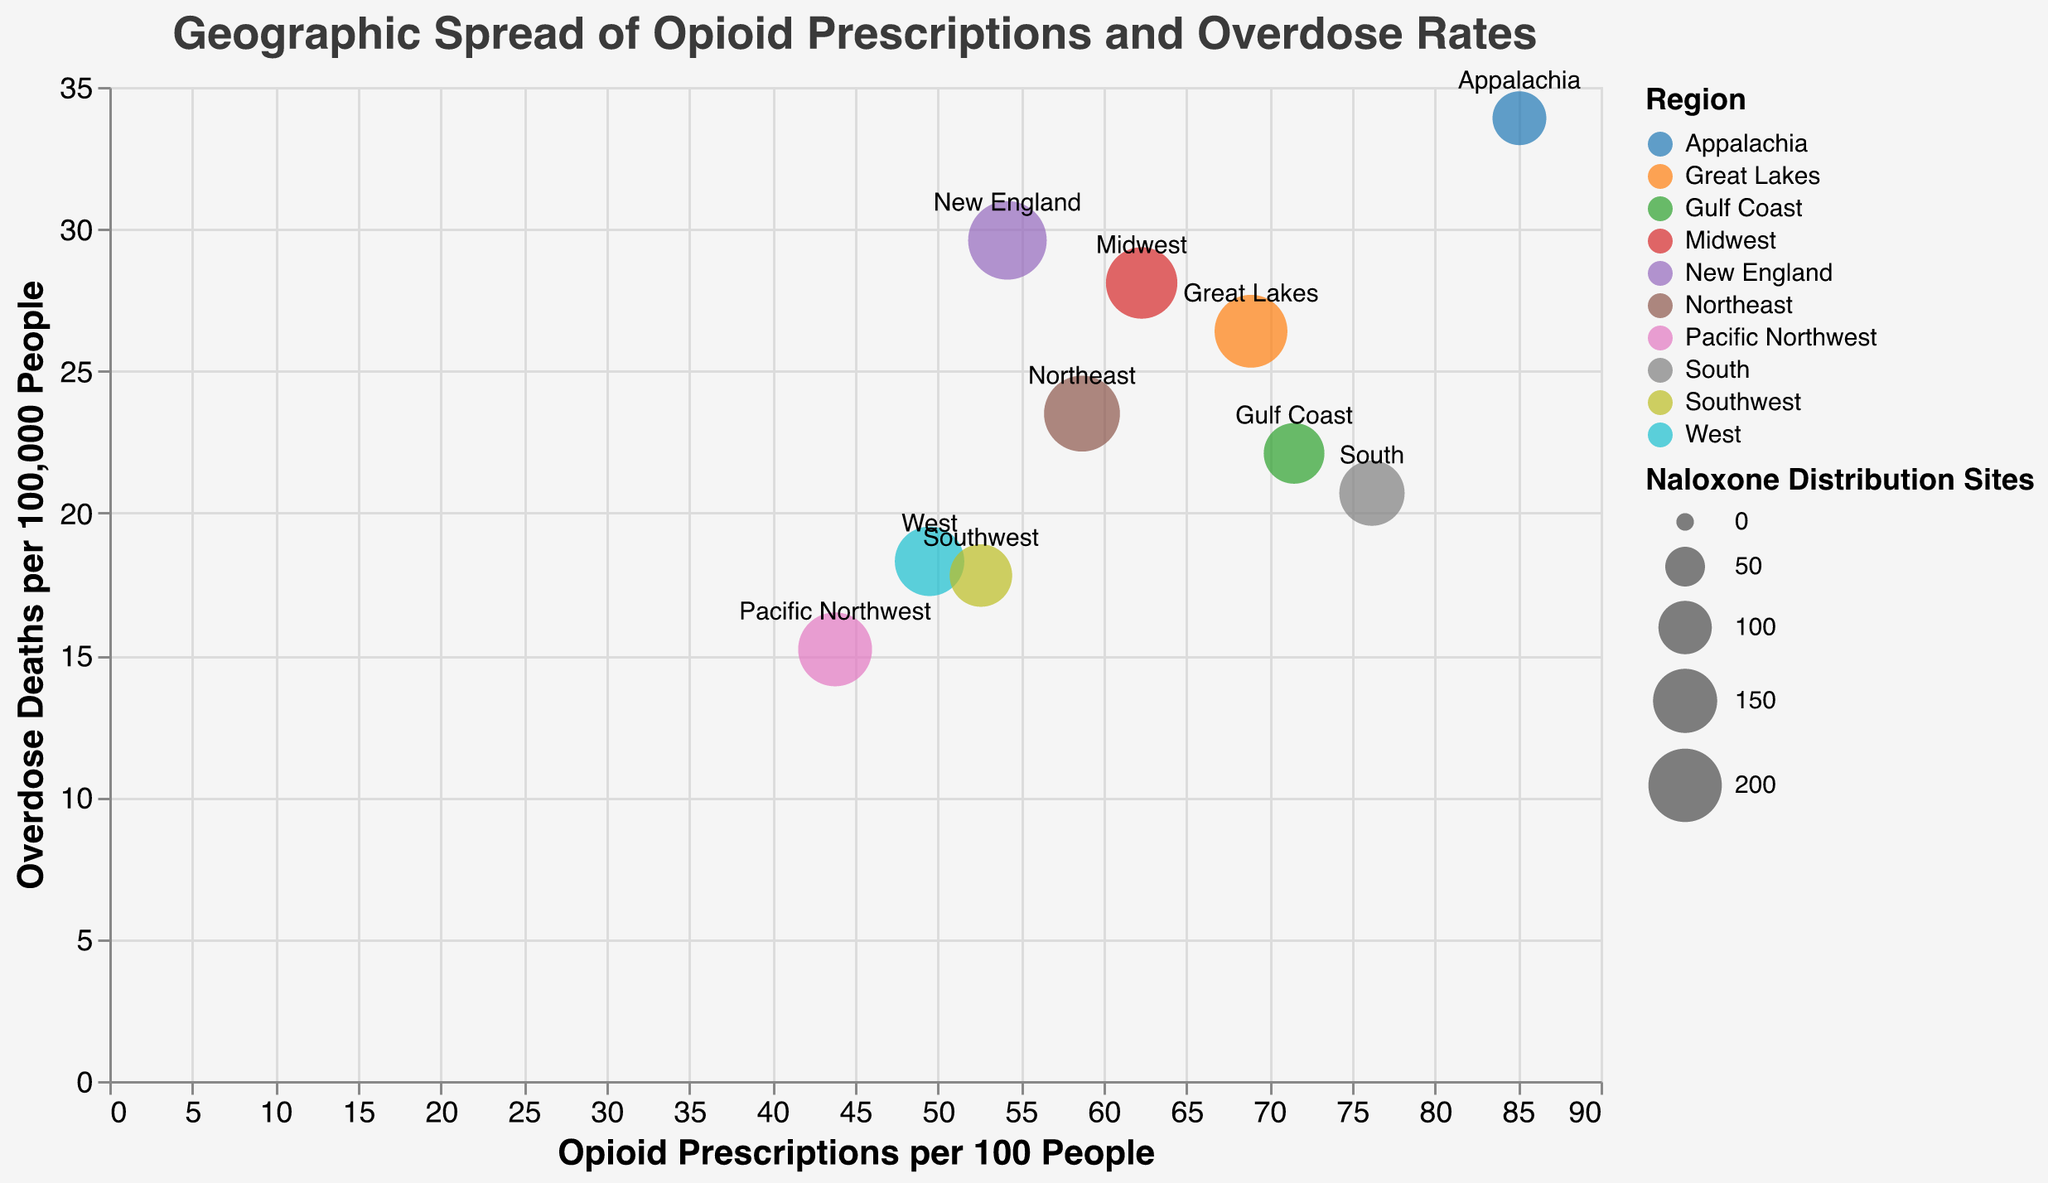What region has the highest rate of opioid prescriptions per 100 people? Look at the x-axis which indicates opioid prescriptions per 100 people and find the region with the highest value on this axis. The highest value is 85.1 in the Appalachia region.
Answer: Appalachia What region has the lowest number of naloxone distribution sites? Find the size of the circles which represents the number of naloxone distribution sites, and identify the smallest circle. The smallest circle corresponds to Appalachia with 102 sites.
Answer: Appalachia Which region has the highest overdose death rate per 100,000 people? Refer to the y-axis which shows overdose deaths per 100,000 people and find the region with the highest value on this axis. The highest overdose death rate is 33.9 in the Appalachia region.
Answer: Appalachia Compare the opioid prescriptions per 100 people between the South and Northeast regions. Locate the South (76.2) and Northeast (58.7) regions on the x-axis (opioid prescriptions). South has more opioid prescriptions per 100 people compared to Northeast.
Answer: South What is the relationship between the number of naloxone distribution sites and the overdose death rates in the Midwest region? Find the Midwest region, identify the size of the circle (189 sites, medium size) and compare this with its y-axis position (28.1 deaths per 100,000). Midwest has a moderate number of naloxone distribution sites but a relatively high overdose death rate.
Answer: Moderate sites, high death rate Calculate the average opioid prescriptions per 100 people in the regions: Northeast, Midwest, and South. Sum the opioid prescriptions per 100 people for these regions: Northeast (58.7), Midwest (62.3), and South (76.2), then divide by the number of regions: (58.7 + 62.3 + 76.2) / 3 = 197.2 / 3.
Answer: 65.7 Which region has more naloxone distribution sites, Pacific Northwest or Great Lakes? Compare the circle sizes corresponding to Pacific Northwest (203 sites) and Great Lakes (197 sites). Pacific Northwest has more naloxone distribution sites.
Answer: Pacific Northwest Is there a correlation between the opioid prescriptions per 100 people and the overdose death rates? Observe the overall trend of the circles. Higher opioid prescriptions per 100 people often correspond to higher overdose death rates, as seen in regions like Appalachia (high in both). This suggests a positive correlation.
Answer: Positive correlation Identify the regions where overdose death rates are lower than 20 per 100,000 people. Look for regions on the y-axis below the 20 mark: West (18.3), Pacific Northwest (15.2), Southwest (17.8).
Answer: West, Pacific Northwest, Southwest How does the naloxone distribution site count affect the overdose death rates in the New England region? Find the New England circle, check the size (231 sites, large) and compare with the y-axis position (29.6 deaths per 100,000). Despite having many naloxone distribution sites, it has a higher overdose death rate, suggesting other factors may influence the death rates.
Answer: Many sites, high death rate 